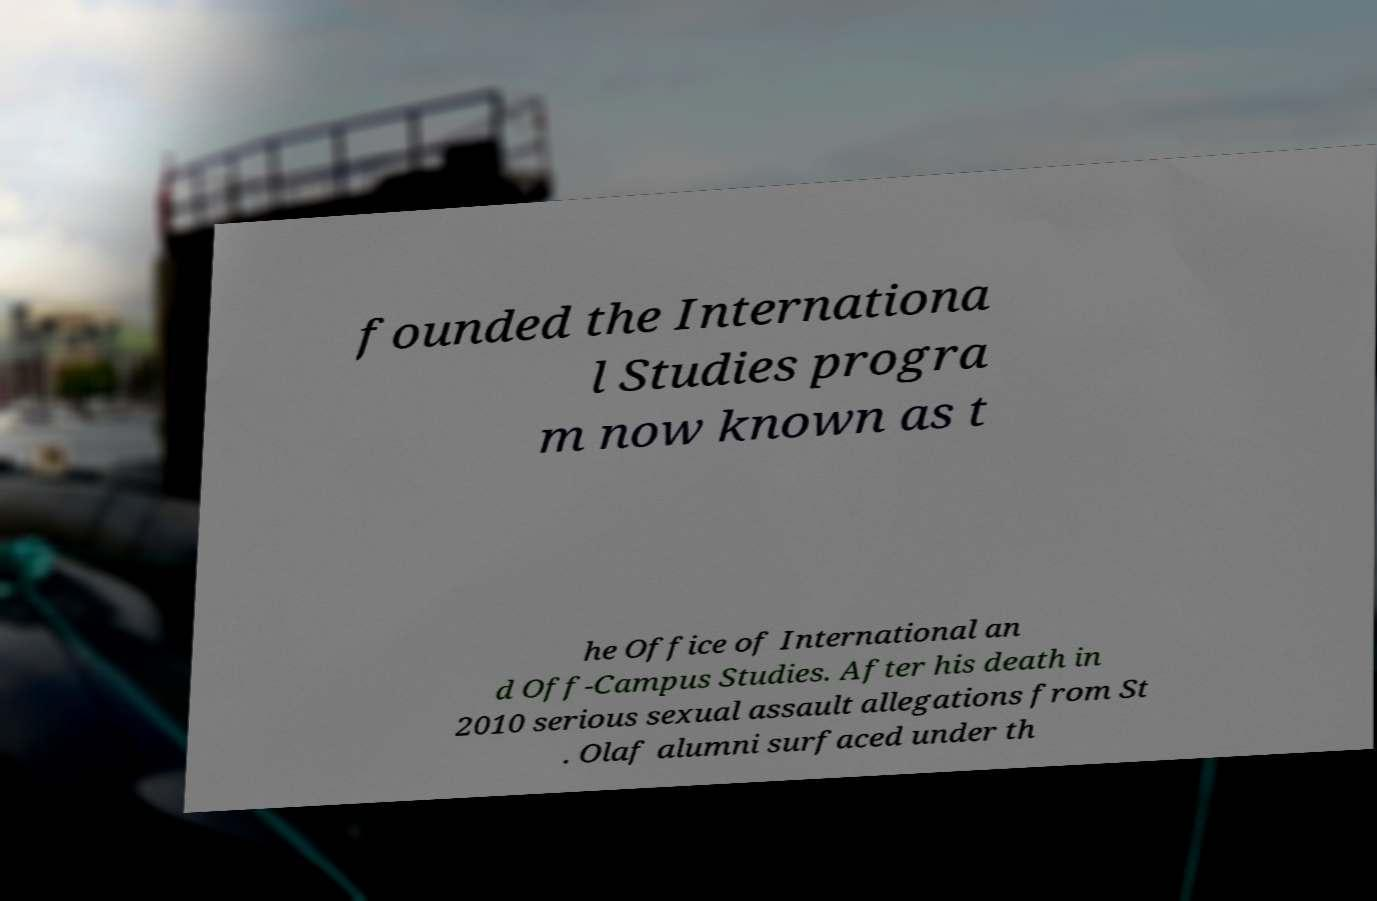For documentation purposes, I need the text within this image transcribed. Could you provide that? founded the Internationa l Studies progra m now known as t he Office of International an d Off-Campus Studies. After his death in 2010 serious sexual assault allegations from St . Olaf alumni surfaced under th 